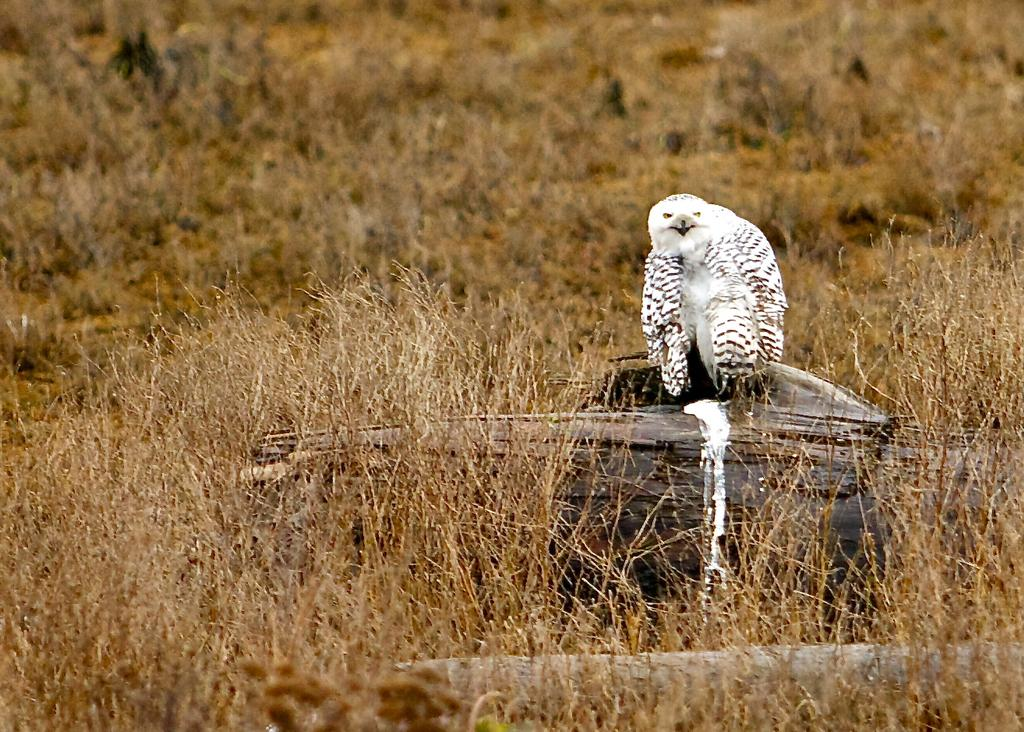What type of animal can be seen in the image? There is a bird in the image. What colors are present on the bird? The bird is white and black in color. What type of vegetation is visible in the image? There is grass visible in the image. How would you describe the background of the image? The background of the image is blurred. What type of bun is being used to hold the bird in the image? There is no bun present in the image, and the bird is not being held by any object. 